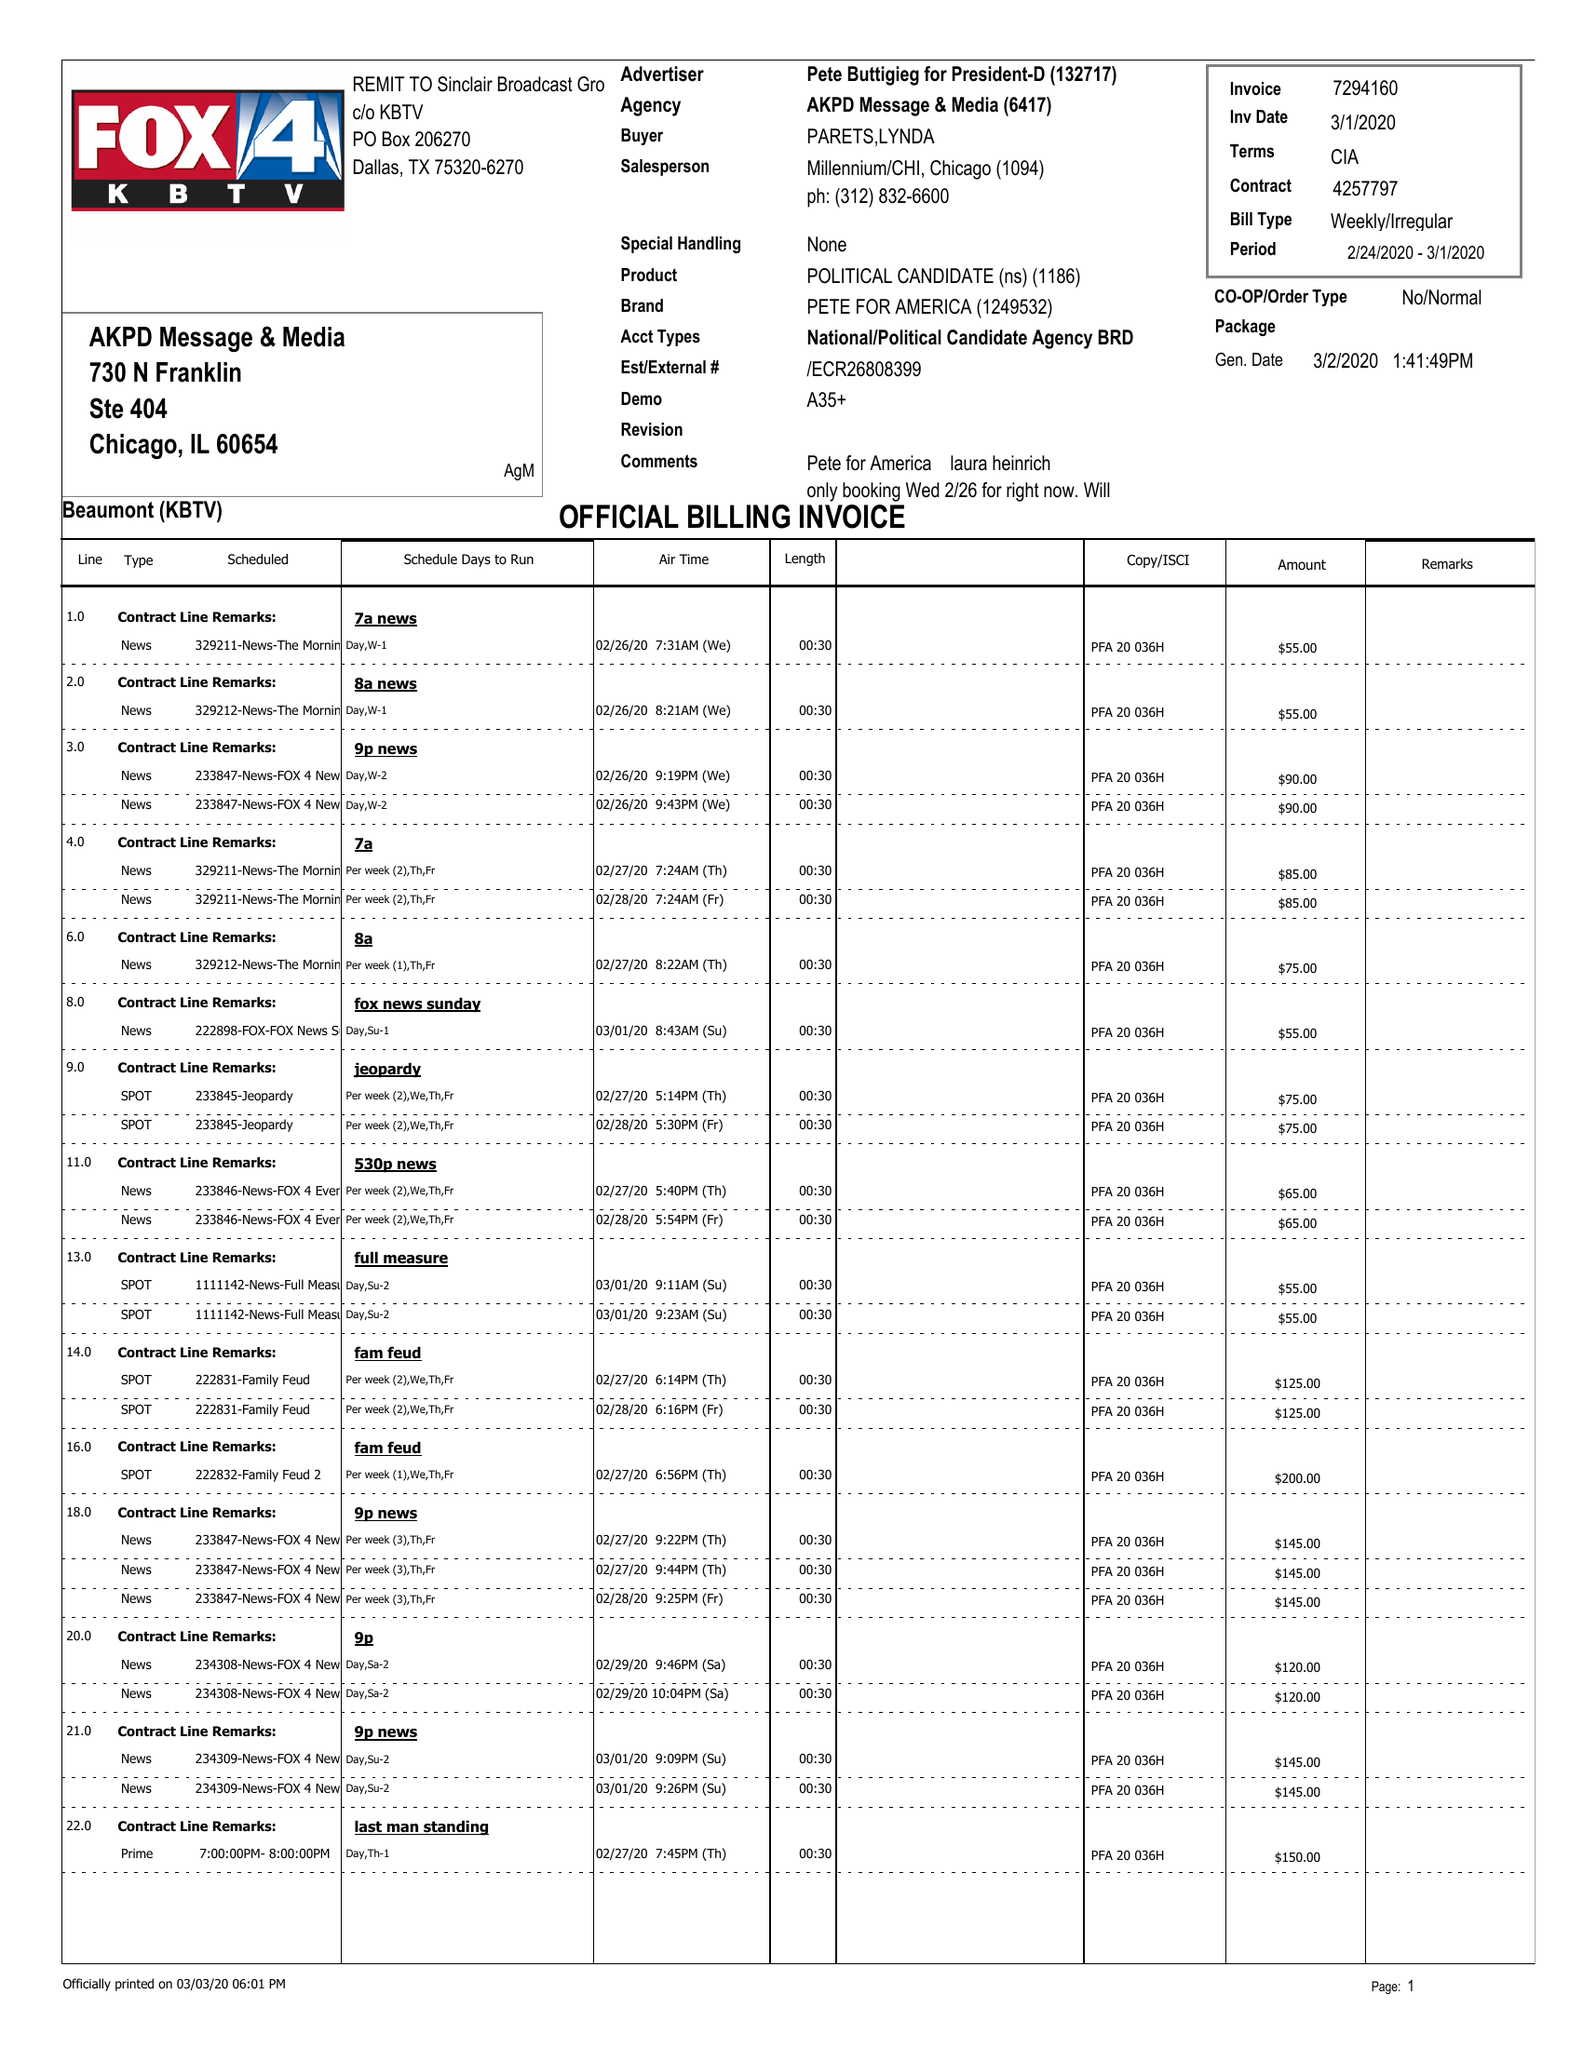What is the value for the flight_from?
Answer the question using a single word or phrase. 02/24/20 